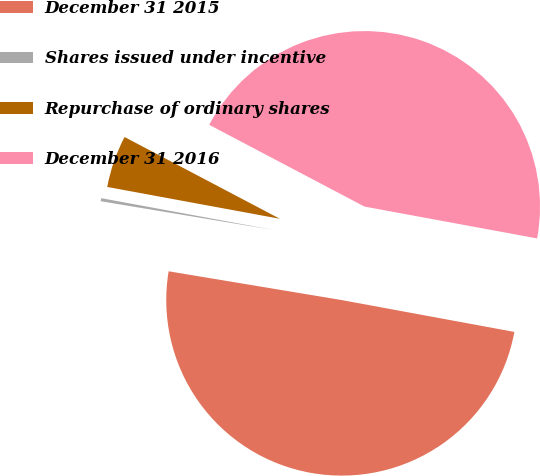Convert chart to OTSL. <chart><loc_0><loc_0><loc_500><loc_500><pie_chart><fcel>December 31 2015<fcel>Shares issued under incentive<fcel>Repurchase of ordinary shares<fcel>December 31 2016<nl><fcel>49.72%<fcel>0.28%<fcel>4.81%<fcel>45.19%<nl></chart> 